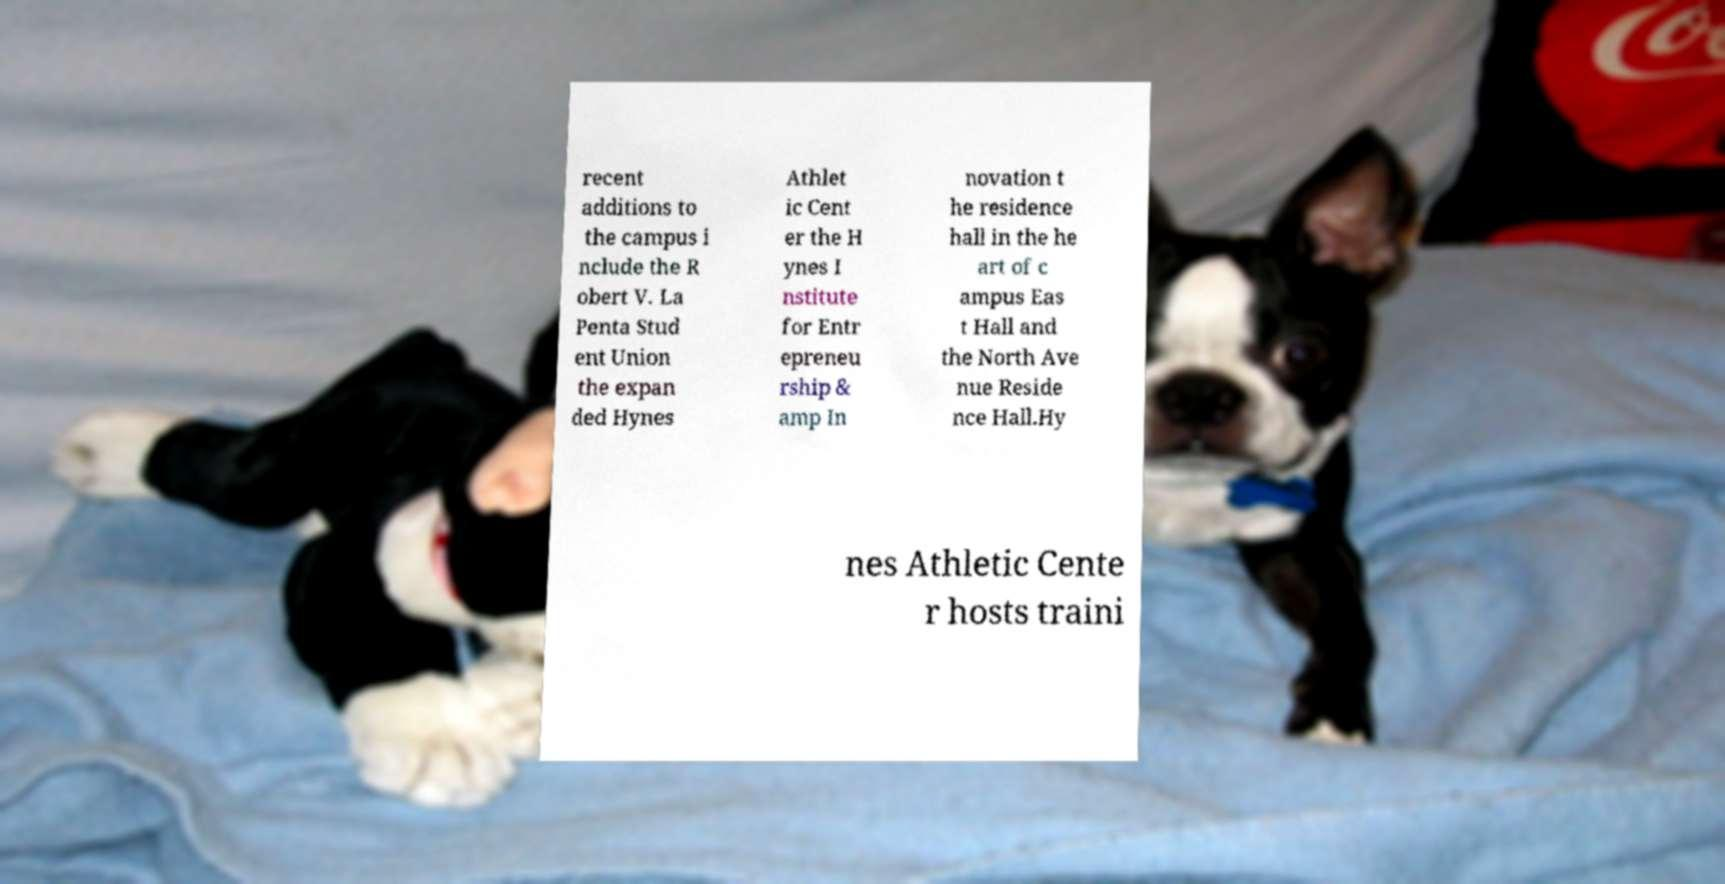What messages or text are displayed in this image? I need them in a readable, typed format. recent additions to the campus i nclude the R obert V. La Penta Stud ent Union the expan ded Hynes Athlet ic Cent er the H ynes I nstitute for Entr epreneu rship & amp In novation t he residence hall in the he art of c ampus Eas t Hall and the North Ave nue Reside nce Hall.Hy nes Athletic Cente r hosts traini 